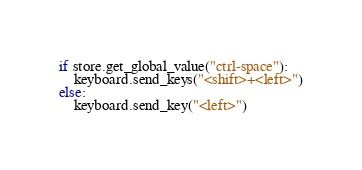<code> <loc_0><loc_0><loc_500><loc_500><_Python_>if store.get_global_value("ctrl-space"):
    keyboard.send_keys("<shift>+<left>")
else:
    keyboard.send_key("<left>")</code> 